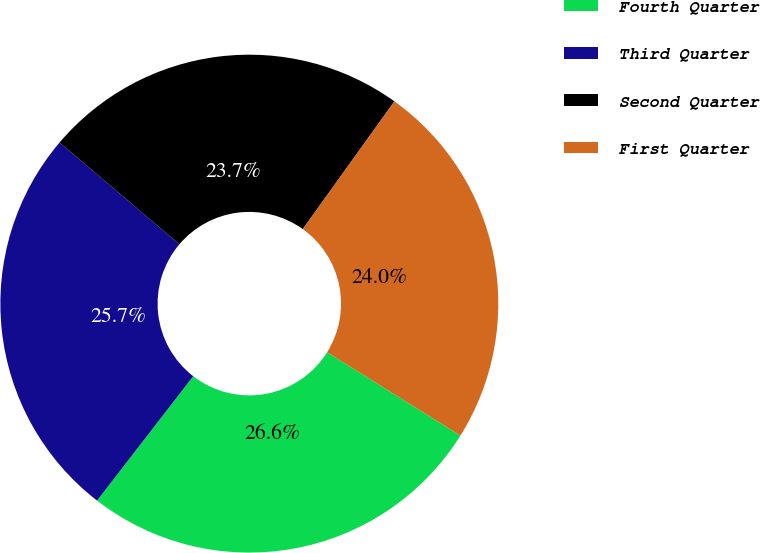<chart> <loc_0><loc_0><loc_500><loc_500><pie_chart><fcel>Fourth Quarter<fcel>Third Quarter<fcel>Second Quarter<fcel>First Quarter<nl><fcel>26.58%<fcel>25.73%<fcel>23.7%<fcel>23.99%<nl></chart> 